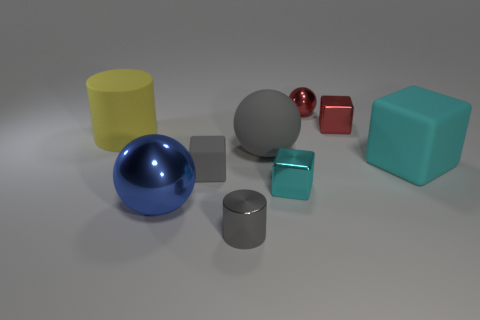What number of other objects are there of the same color as the small shiny cylinder?
Your answer should be compact. 2. There is a cyan shiny thing that is the same size as the gray cube; what shape is it?
Keep it short and to the point. Cube. The metal block that is in front of the big yellow thing is what color?
Offer a terse response. Cyan. What number of objects are small objects that are to the left of the small gray cylinder or balls right of the small cyan cube?
Offer a terse response. 2. Is the gray metallic cylinder the same size as the yellow cylinder?
Offer a very short reply. No. What number of blocks are large yellow rubber things or cyan matte objects?
Provide a succinct answer. 1. How many large objects are both behind the small cyan metallic cube and to the left of the red metal block?
Ensure brevity in your answer.  2. There is a yellow cylinder; is its size the same as the cyan object that is to the left of the tiny red block?
Provide a short and direct response. No. There is a cube that is left of the large ball right of the blue metallic thing; is there a cylinder in front of it?
Offer a very short reply. Yes. There is a tiny red thing that is behind the cube behind the large yellow object; what is its material?
Make the answer very short. Metal. 